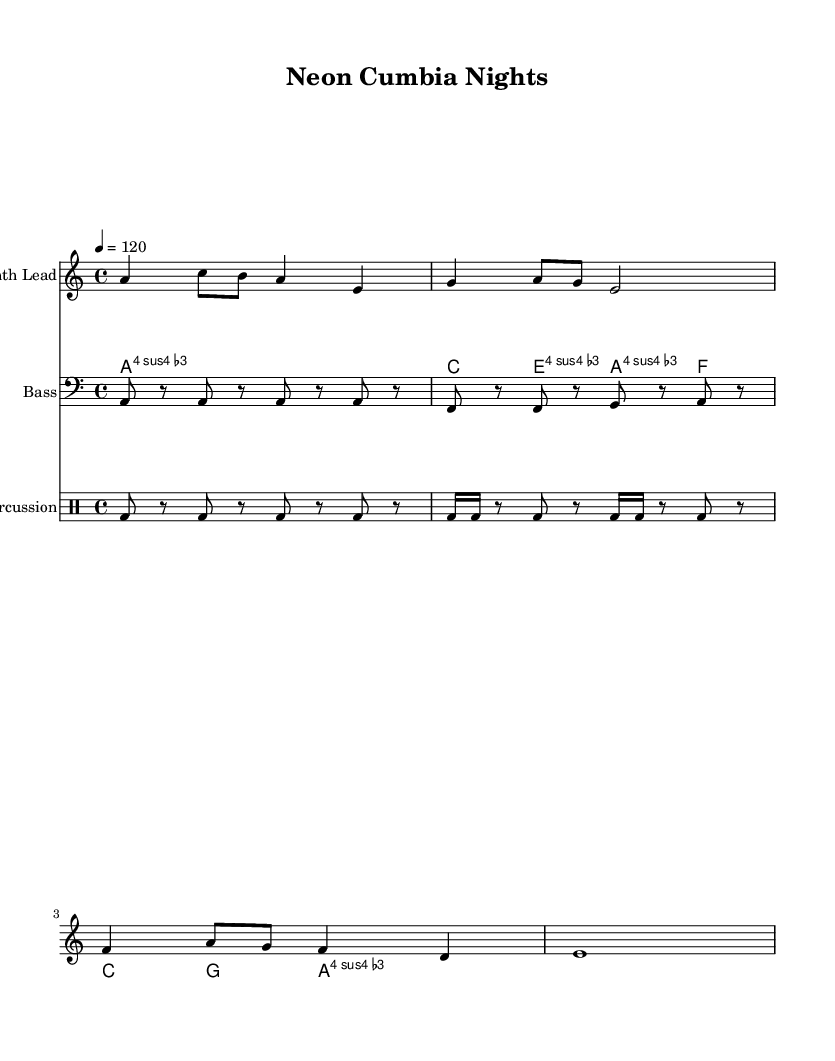What is the key signature of this music? The key signature is A minor, which has no sharps or flats.
Answer: A minor What is the time signature of this music? The time signature is 4/4, indicated as a fraction at the beginning of the piece.
Answer: 4/4 What is the tempo marking for this piece? The tempo marking is 4 beats per minute, indicated as "4 = 120" in the score.
Answer: 120 What chords are used in the cumbia rhythm section? The cumbia rhythm section consists of A minor, C major, E minor, F major, G major, and A minor chords, as indicated in the chord progression.
Answer: A minor, C major, E minor, F major, G major How many beats does the synth lead's first measure contain? The first measure of the synth lead contains 4 beats, as indicated by the notation of four quarter notes and eighth notes that fit within the measure.
Answer: 4 beats What is the duration of the last note in the synth lead? The last note in the synth lead is a whole note, indicated by the notation of a single note that covers the entire measure bar.
Answer: Whole note What unique rhythmic feature characterizes the electronic percussion in this remix? The electronic percussion showcases a syncopated pattern, with a mix of quarter notes and sixteenth notes creating a dynamic rhythm.
Answer: Syncopation 